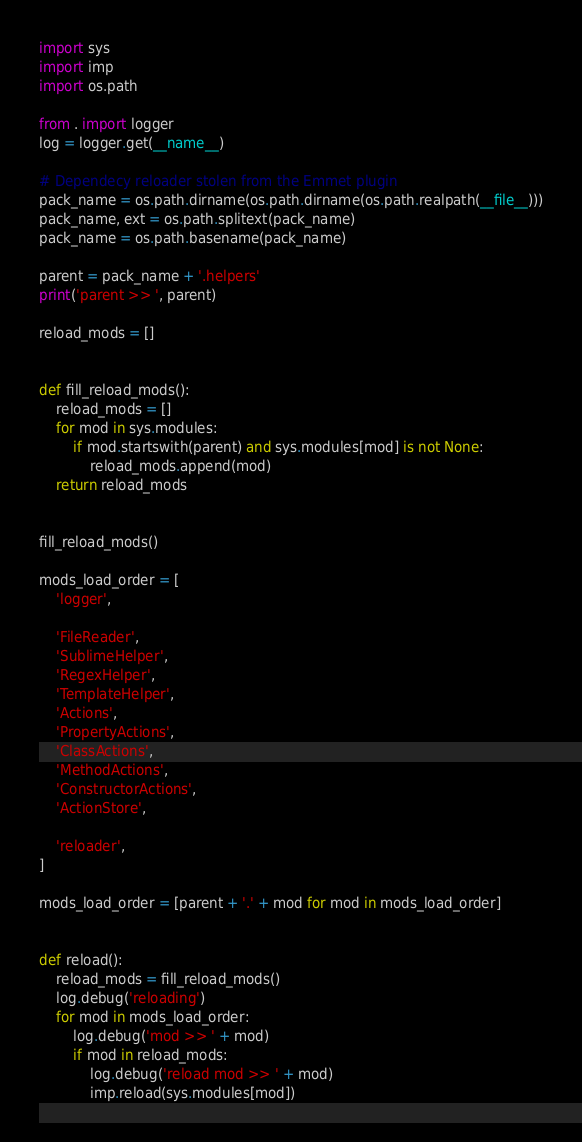Convert code to text. <code><loc_0><loc_0><loc_500><loc_500><_Python_>import sys
import imp
import os.path

from . import logger
log = logger.get(__name__)

# Dependecy reloader stolen from the Emmet plugin
pack_name = os.path.dirname(os.path.dirname(os.path.realpath(__file__)))
pack_name, ext = os.path.splitext(pack_name)
pack_name = os.path.basename(pack_name)

parent = pack_name + '.helpers'
print('parent >> ', parent)

reload_mods = []


def fill_reload_mods():
    reload_mods = []
    for mod in sys.modules:
        if mod.startswith(parent) and sys.modules[mod] is not None:
            reload_mods.append(mod)
    return reload_mods


fill_reload_mods()

mods_load_order = [
    'logger',

    'FileReader',
    'SublimeHelper',
    'RegexHelper',
    'TemplateHelper',
    'Actions',
    'PropertyActions',
    'ClassActions',
    'MethodActions',
    'ConstructorActions',
    'ActionStore',

    'reloader',
]

mods_load_order = [parent + '.' + mod for mod in mods_load_order]


def reload():
    reload_mods = fill_reload_mods()
    log.debug('reloading')
    for mod in mods_load_order:
        log.debug('mod >> ' + mod)
        if mod in reload_mods:
            log.debug('reload mod >> ' + mod)
            imp.reload(sys.modules[mod])
</code> 